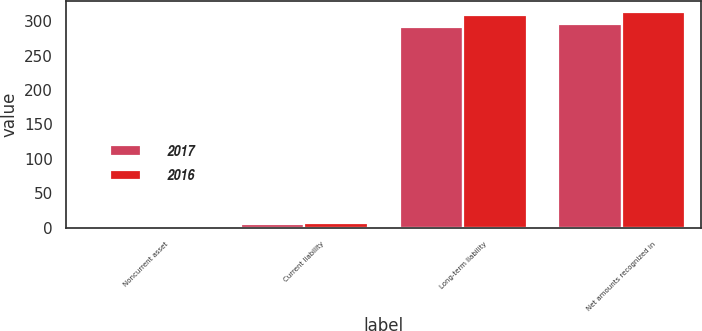Convert chart to OTSL. <chart><loc_0><loc_0><loc_500><loc_500><stacked_bar_chart><ecel><fcel>Noncurrent asset<fcel>Current liability<fcel>Long-term liability<fcel>Net amounts recognized in<nl><fcel>2017<fcel>1<fcel>5<fcel>292<fcel>296<nl><fcel>2016<fcel>1<fcel>6<fcel>309<fcel>314<nl></chart> 